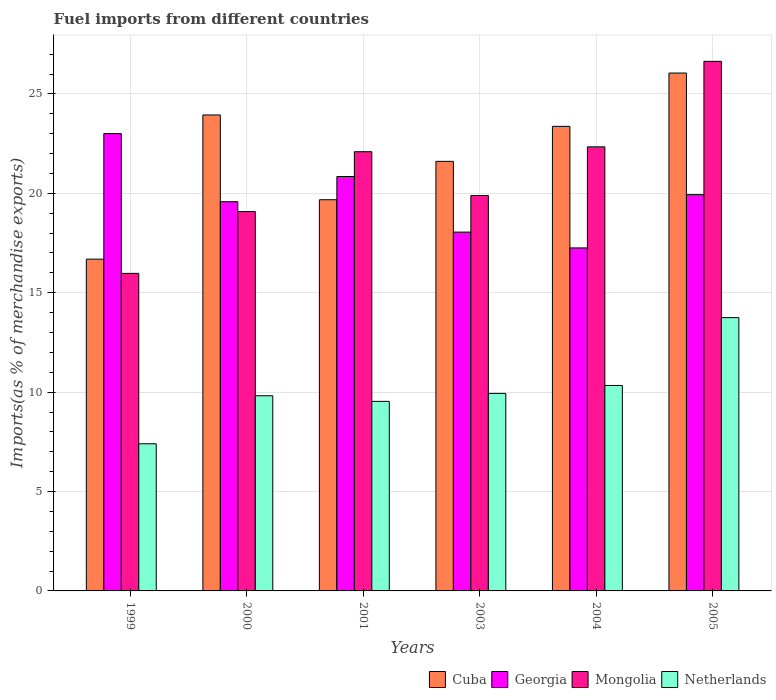Are the number of bars per tick equal to the number of legend labels?
Make the answer very short. Yes. How many bars are there on the 6th tick from the left?
Your answer should be very brief. 4. How many bars are there on the 3rd tick from the right?
Provide a succinct answer. 4. What is the percentage of imports to different countries in Mongolia in 2004?
Provide a short and direct response. 22.34. Across all years, what is the maximum percentage of imports to different countries in Netherlands?
Give a very brief answer. 13.75. Across all years, what is the minimum percentage of imports to different countries in Georgia?
Provide a succinct answer. 17.25. In which year was the percentage of imports to different countries in Georgia minimum?
Offer a terse response. 2004. What is the total percentage of imports to different countries in Georgia in the graph?
Give a very brief answer. 118.67. What is the difference between the percentage of imports to different countries in Georgia in 2001 and that in 2005?
Give a very brief answer. 0.91. What is the difference between the percentage of imports to different countries in Mongolia in 2000 and the percentage of imports to different countries in Cuba in 2001?
Make the answer very short. -0.6. What is the average percentage of imports to different countries in Georgia per year?
Make the answer very short. 19.78. In the year 2003, what is the difference between the percentage of imports to different countries in Netherlands and percentage of imports to different countries in Mongolia?
Give a very brief answer. -9.96. In how many years, is the percentage of imports to different countries in Mongolia greater than 20 %?
Your answer should be very brief. 3. What is the ratio of the percentage of imports to different countries in Cuba in 1999 to that in 2004?
Ensure brevity in your answer.  0.71. Is the percentage of imports to different countries in Netherlands in 2003 less than that in 2005?
Ensure brevity in your answer.  Yes. Is the difference between the percentage of imports to different countries in Netherlands in 1999 and 2000 greater than the difference between the percentage of imports to different countries in Mongolia in 1999 and 2000?
Ensure brevity in your answer.  Yes. What is the difference between the highest and the second highest percentage of imports to different countries in Georgia?
Your response must be concise. 2.16. What is the difference between the highest and the lowest percentage of imports to different countries in Mongolia?
Ensure brevity in your answer.  10.67. In how many years, is the percentage of imports to different countries in Mongolia greater than the average percentage of imports to different countries in Mongolia taken over all years?
Give a very brief answer. 3. Is it the case that in every year, the sum of the percentage of imports to different countries in Georgia and percentage of imports to different countries in Mongolia is greater than the sum of percentage of imports to different countries in Cuba and percentage of imports to different countries in Netherlands?
Ensure brevity in your answer.  Yes. What does the 2nd bar from the left in 2004 represents?
Offer a very short reply. Georgia. What does the 3rd bar from the right in 2001 represents?
Provide a succinct answer. Georgia. How many bars are there?
Your answer should be very brief. 24. Are all the bars in the graph horizontal?
Keep it short and to the point. No. Where does the legend appear in the graph?
Give a very brief answer. Bottom right. How many legend labels are there?
Your answer should be compact. 4. How are the legend labels stacked?
Your answer should be very brief. Horizontal. What is the title of the graph?
Give a very brief answer. Fuel imports from different countries. Does "Israel" appear as one of the legend labels in the graph?
Ensure brevity in your answer.  No. What is the label or title of the X-axis?
Ensure brevity in your answer.  Years. What is the label or title of the Y-axis?
Your answer should be compact. Imports(as % of merchandise exports). What is the Imports(as % of merchandise exports) in Cuba in 1999?
Your response must be concise. 16.69. What is the Imports(as % of merchandise exports) of Georgia in 1999?
Provide a short and direct response. 23. What is the Imports(as % of merchandise exports) in Mongolia in 1999?
Provide a succinct answer. 15.97. What is the Imports(as % of merchandise exports) of Netherlands in 1999?
Your answer should be very brief. 7.4. What is the Imports(as % of merchandise exports) of Cuba in 2000?
Give a very brief answer. 23.94. What is the Imports(as % of merchandise exports) in Georgia in 2000?
Your answer should be very brief. 19.58. What is the Imports(as % of merchandise exports) of Mongolia in 2000?
Provide a short and direct response. 19.08. What is the Imports(as % of merchandise exports) of Netherlands in 2000?
Keep it short and to the point. 9.82. What is the Imports(as % of merchandise exports) of Cuba in 2001?
Your answer should be compact. 19.68. What is the Imports(as % of merchandise exports) in Georgia in 2001?
Keep it short and to the point. 20.85. What is the Imports(as % of merchandise exports) in Mongolia in 2001?
Your answer should be very brief. 22.09. What is the Imports(as % of merchandise exports) of Netherlands in 2001?
Make the answer very short. 9.53. What is the Imports(as % of merchandise exports) of Cuba in 2003?
Provide a succinct answer. 21.61. What is the Imports(as % of merchandise exports) in Georgia in 2003?
Provide a succinct answer. 18.05. What is the Imports(as % of merchandise exports) in Mongolia in 2003?
Offer a terse response. 19.89. What is the Imports(as % of merchandise exports) in Netherlands in 2003?
Your answer should be compact. 9.93. What is the Imports(as % of merchandise exports) in Cuba in 2004?
Make the answer very short. 23.37. What is the Imports(as % of merchandise exports) in Georgia in 2004?
Give a very brief answer. 17.25. What is the Imports(as % of merchandise exports) in Mongolia in 2004?
Offer a very short reply. 22.34. What is the Imports(as % of merchandise exports) of Netherlands in 2004?
Ensure brevity in your answer.  10.34. What is the Imports(as % of merchandise exports) of Cuba in 2005?
Keep it short and to the point. 26.05. What is the Imports(as % of merchandise exports) of Georgia in 2005?
Your answer should be very brief. 19.93. What is the Imports(as % of merchandise exports) of Mongolia in 2005?
Your answer should be compact. 26.64. What is the Imports(as % of merchandise exports) in Netherlands in 2005?
Offer a terse response. 13.75. Across all years, what is the maximum Imports(as % of merchandise exports) in Cuba?
Your answer should be compact. 26.05. Across all years, what is the maximum Imports(as % of merchandise exports) in Georgia?
Give a very brief answer. 23. Across all years, what is the maximum Imports(as % of merchandise exports) in Mongolia?
Offer a very short reply. 26.64. Across all years, what is the maximum Imports(as % of merchandise exports) in Netherlands?
Provide a short and direct response. 13.75. Across all years, what is the minimum Imports(as % of merchandise exports) in Cuba?
Your answer should be compact. 16.69. Across all years, what is the minimum Imports(as % of merchandise exports) in Georgia?
Provide a short and direct response. 17.25. Across all years, what is the minimum Imports(as % of merchandise exports) in Mongolia?
Ensure brevity in your answer.  15.97. Across all years, what is the minimum Imports(as % of merchandise exports) of Netherlands?
Provide a succinct answer. 7.4. What is the total Imports(as % of merchandise exports) in Cuba in the graph?
Offer a terse response. 131.34. What is the total Imports(as % of merchandise exports) of Georgia in the graph?
Offer a very short reply. 118.67. What is the total Imports(as % of merchandise exports) of Mongolia in the graph?
Ensure brevity in your answer.  126.02. What is the total Imports(as % of merchandise exports) in Netherlands in the graph?
Offer a terse response. 60.77. What is the difference between the Imports(as % of merchandise exports) in Cuba in 1999 and that in 2000?
Make the answer very short. -7.25. What is the difference between the Imports(as % of merchandise exports) in Georgia in 1999 and that in 2000?
Your answer should be very brief. 3.42. What is the difference between the Imports(as % of merchandise exports) in Mongolia in 1999 and that in 2000?
Keep it short and to the point. -3.11. What is the difference between the Imports(as % of merchandise exports) in Netherlands in 1999 and that in 2000?
Make the answer very short. -2.42. What is the difference between the Imports(as % of merchandise exports) of Cuba in 1999 and that in 2001?
Offer a very short reply. -2.99. What is the difference between the Imports(as % of merchandise exports) of Georgia in 1999 and that in 2001?
Your answer should be compact. 2.16. What is the difference between the Imports(as % of merchandise exports) in Mongolia in 1999 and that in 2001?
Provide a succinct answer. -6.12. What is the difference between the Imports(as % of merchandise exports) of Netherlands in 1999 and that in 2001?
Provide a succinct answer. -2.13. What is the difference between the Imports(as % of merchandise exports) in Cuba in 1999 and that in 2003?
Ensure brevity in your answer.  -4.92. What is the difference between the Imports(as % of merchandise exports) of Georgia in 1999 and that in 2003?
Give a very brief answer. 4.95. What is the difference between the Imports(as % of merchandise exports) of Mongolia in 1999 and that in 2003?
Keep it short and to the point. -3.92. What is the difference between the Imports(as % of merchandise exports) of Netherlands in 1999 and that in 2003?
Ensure brevity in your answer.  -2.53. What is the difference between the Imports(as % of merchandise exports) in Cuba in 1999 and that in 2004?
Make the answer very short. -6.68. What is the difference between the Imports(as % of merchandise exports) of Georgia in 1999 and that in 2004?
Your response must be concise. 5.75. What is the difference between the Imports(as % of merchandise exports) in Mongolia in 1999 and that in 2004?
Offer a very short reply. -6.37. What is the difference between the Imports(as % of merchandise exports) in Netherlands in 1999 and that in 2004?
Your answer should be very brief. -2.93. What is the difference between the Imports(as % of merchandise exports) of Cuba in 1999 and that in 2005?
Offer a terse response. -9.36. What is the difference between the Imports(as % of merchandise exports) in Georgia in 1999 and that in 2005?
Offer a very short reply. 3.07. What is the difference between the Imports(as % of merchandise exports) in Mongolia in 1999 and that in 2005?
Provide a succinct answer. -10.67. What is the difference between the Imports(as % of merchandise exports) of Netherlands in 1999 and that in 2005?
Make the answer very short. -6.35. What is the difference between the Imports(as % of merchandise exports) in Cuba in 2000 and that in 2001?
Offer a terse response. 4.26. What is the difference between the Imports(as % of merchandise exports) of Georgia in 2000 and that in 2001?
Make the answer very short. -1.27. What is the difference between the Imports(as % of merchandise exports) of Mongolia in 2000 and that in 2001?
Offer a very short reply. -3.01. What is the difference between the Imports(as % of merchandise exports) of Netherlands in 2000 and that in 2001?
Provide a succinct answer. 0.28. What is the difference between the Imports(as % of merchandise exports) in Cuba in 2000 and that in 2003?
Your answer should be compact. 2.33. What is the difference between the Imports(as % of merchandise exports) of Georgia in 2000 and that in 2003?
Your answer should be very brief. 1.53. What is the difference between the Imports(as % of merchandise exports) in Mongolia in 2000 and that in 2003?
Your answer should be very brief. -0.81. What is the difference between the Imports(as % of merchandise exports) of Netherlands in 2000 and that in 2003?
Provide a short and direct response. -0.12. What is the difference between the Imports(as % of merchandise exports) of Cuba in 2000 and that in 2004?
Make the answer very short. 0.57. What is the difference between the Imports(as % of merchandise exports) of Georgia in 2000 and that in 2004?
Make the answer very short. 2.33. What is the difference between the Imports(as % of merchandise exports) in Mongolia in 2000 and that in 2004?
Your answer should be compact. -3.26. What is the difference between the Imports(as % of merchandise exports) in Netherlands in 2000 and that in 2004?
Offer a very short reply. -0.52. What is the difference between the Imports(as % of merchandise exports) of Cuba in 2000 and that in 2005?
Your response must be concise. -2.11. What is the difference between the Imports(as % of merchandise exports) of Georgia in 2000 and that in 2005?
Provide a succinct answer. -0.36. What is the difference between the Imports(as % of merchandise exports) of Mongolia in 2000 and that in 2005?
Keep it short and to the point. -7.56. What is the difference between the Imports(as % of merchandise exports) of Netherlands in 2000 and that in 2005?
Your answer should be compact. -3.93. What is the difference between the Imports(as % of merchandise exports) in Cuba in 2001 and that in 2003?
Ensure brevity in your answer.  -1.93. What is the difference between the Imports(as % of merchandise exports) of Georgia in 2001 and that in 2003?
Keep it short and to the point. 2.8. What is the difference between the Imports(as % of merchandise exports) in Mongolia in 2001 and that in 2003?
Your answer should be compact. 2.2. What is the difference between the Imports(as % of merchandise exports) in Netherlands in 2001 and that in 2003?
Keep it short and to the point. -0.4. What is the difference between the Imports(as % of merchandise exports) in Cuba in 2001 and that in 2004?
Your answer should be very brief. -3.69. What is the difference between the Imports(as % of merchandise exports) in Georgia in 2001 and that in 2004?
Make the answer very short. 3.59. What is the difference between the Imports(as % of merchandise exports) in Mongolia in 2001 and that in 2004?
Give a very brief answer. -0.24. What is the difference between the Imports(as % of merchandise exports) in Netherlands in 2001 and that in 2004?
Provide a short and direct response. -0.8. What is the difference between the Imports(as % of merchandise exports) of Cuba in 2001 and that in 2005?
Give a very brief answer. -6.37. What is the difference between the Imports(as % of merchandise exports) in Georgia in 2001 and that in 2005?
Provide a succinct answer. 0.91. What is the difference between the Imports(as % of merchandise exports) in Mongolia in 2001 and that in 2005?
Provide a succinct answer. -4.54. What is the difference between the Imports(as % of merchandise exports) of Netherlands in 2001 and that in 2005?
Provide a succinct answer. -4.21. What is the difference between the Imports(as % of merchandise exports) of Cuba in 2003 and that in 2004?
Your answer should be very brief. -1.76. What is the difference between the Imports(as % of merchandise exports) of Georgia in 2003 and that in 2004?
Your answer should be very brief. 0.8. What is the difference between the Imports(as % of merchandise exports) of Mongolia in 2003 and that in 2004?
Your answer should be compact. -2.45. What is the difference between the Imports(as % of merchandise exports) in Netherlands in 2003 and that in 2004?
Your answer should be compact. -0.4. What is the difference between the Imports(as % of merchandise exports) of Cuba in 2003 and that in 2005?
Keep it short and to the point. -4.44. What is the difference between the Imports(as % of merchandise exports) of Georgia in 2003 and that in 2005?
Offer a terse response. -1.89. What is the difference between the Imports(as % of merchandise exports) of Mongolia in 2003 and that in 2005?
Keep it short and to the point. -6.75. What is the difference between the Imports(as % of merchandise exports) of Netherlands in 2003 and that in 2005?
Provide a short and direct response. -3.81. What is the difference between the Imports(as % of merchandise exports) of Cuba in 2004 and that in 2005?
Offer a terse response. -2.68. What is the difference between the Imports(as % of merchandise exports) of Georgia in 2004 and that in 2005?
Offer a very short reply. -2.68. What is the difference between the Imports(as % of merchandise exports) of Mongolia in 2004 and that in 2005?
Your answer should be very brief. -4.3. What is the difference between the Imports(as % of merchandise exports) of Netherlands in 2004 and that in 2005?
Your answer should be very brief. -3.41. What is the difference between the Imports(as % of merchandise exports) in Cuba in 1999 and the Imports(as % of merchandise exports) in Georgia in 2000?
Provide a succinct answer. -2.89. What is the difference between the Imports(as % of merchandise exports) in Cuba in 1999 and the Imports(as % of merchandise exports) in Mongolia in 2000?
Ensure brevity in your answer.  -2.39. What is the difference between the Imports(as % of merchandise exports) in Cuba in 1999 and the Imports(as % of merchandise exports) in Netherlands in 2000?
Offer a very short reply. 6.87. What is the difference between the Imports(as % of merchandise exports) of Georgia in 1999 and the Imports(as % of merchandise exports) of Mongolia in 2000?
Provide a short and direct response. 3.92. What is the difference between the Imports(as % of merchandise exports) in Georgia in 1999 and the Imports(as % of merchandise exports) in Netherlands in 2000?
Keep it short and to the point. 13.19. What is the difference between the Imports(as % of merchandise exports) in Mongolia in 1999 and the Imports(as % of merchandise exports) in Netherlands in 2000?
Your answer should be very brief. 6.16. What is the difference between the Imports(as % of merchandise exports) in Cuba in 1999 and the Imports(as % of merchandise exports) in Georgia in 2001?
Keep it short and to the point. -4.16. What is the difference between the Imports(as % of merchandise exports) of Cuba in 1999 and the Imports(as % of merchandise exports) of Mongolia in 2001?
Make the answer very short. -5.4. What is the difference between the Imports(as % of merchandise exports) of Cuba in 1999 and the Imports(as % of merchandise exports) of Netherlands in 2001?
Give a very brief answer. 7.16. What is the difference between the Imports(as % of merchandise exports) of Georgia in 1999 and the Imports(as % of merchandise exports) of Mongolia in 2001?
Your answer should be very brief. 0.91. What is the difference between the Imports(as % of merchandise exports) of Georgia in 1999 and the Imports(as % of merchandise exports) of Netherlands in 2001?
Ensure brevity in your answer.  13.47. What is the difference between the Imports(as % of merchandise exports) of Mongolia in 1999 and the Imports(as % of merchandise exports) of Netherlands in 2001?
Make the answer very short. 6.44. What is the difference between the Imports(as % of merchandise exports) of Cuba in 1999 and the Imports(as % of merchandise exports) of Georgia in 2003?
Ensure brevity in your answer.  -1.36. What is the difference between the Imports(as % of merchandise exports) of Cuba in 1999 and the Imports(as % of merchandise exports) of Mongolia in 2003?
Your answer should be compact. -3.2. What is the difference between the Imports(as % of merchandise exports) of Cuba in 1999 and the Imports(as % of merchandise exports) of Netherlands in 2003?
Ensure brevity in your answer.  6.76. What is the difference between the Imports(as % of merchandise exports) in Georgia in 1999 and the Imports(as % of merchandise exports) in Mongolia in 2003?
Give a very brief answer. 3.11. What is the difference between the Imports(as % of merchandise exports) in Georgia in 1999 and the Imports(as % of merchandise exports) in Netherlands in 2003?
Your response must be concise. 13.07. What is the difference between the Imports(as % of merchandise exports) in Mongolia in 1999 and the Imports(as % of merchandise exports) in Netherlands in 2003?
Ensure brevity in your answer.  6.04. What is the difference between the Imports(as % of merchandise exports) of Cuba in 1999 and the Imports(as % of merchandise exports) of Georgia in 2004?
Offer a terse response. -0.56. What is the difference between the Imports(as % of merchandise exports) of Cuba in 1999 and the Imports(as % of merchandise exports) of Mongolia in 2004?
Offer a very short reply. -5.65. What is the difference between the Imports(as % of merchandise exports) in Cuba in 1999 and the Imports(as % of merchandise exports) in Netherlands in 2004?
Provide a succinct answer. 6.35. What is the difference between the Imports(as % of merchandise exports) of Georgia in 1999 and the Imports(as % of merchandise exports) of Mongolia in 2004?
Ensure brevity in your answer.  0.67. What is the difference between the Imports(as % of merchandise exports) in Georgia in 1999 and the Imports(as % of merchandise exports) in Netherlands in 2004?
Your answer should be very brief. 12.67. What is the difference between the Imports(as % of merchandise exports) in Mongolia in 1999 and the Imports(as % of merchandise exports) in Netherlands in 2004?
Ensure brevity in your answer.  5.64. What is the difference between the Imports(as % of merchandise exports) of Cuba in 1999 and the Imports(as % of merchandise exports) of Georgia in 2005?
Make the answer very short. -3.24. What is the difference between the Imports(as % of merchandise exports) in Cuba in 1999 and the Imports(as % of merchandise exports) in Mongolia in 2005?
Offer a very short reply. -9.95. What is the difference between the Imports(as % of merchandise exports) in Cuba in 1999 and the Imports(as % of merchandise exports) in Netherlands in 2005?
Your answer should be compact. 2.94. What is the difference between the Imports(as % of merchandise exports) of Georgia in 1999 and the Imports(as % of merchandise exports) of Mongolia in 2005?
Make the answer very short. -3.63. What is the difference between the Imports(as % of merchandise exports) of Georgia in 1999 and the Imports(as % of merchandise exports) of Netherlands in 2005?
Offer a very short reply. 9.26. What is the difference between the Imports(as % of merchandise exports) in Mongolia in 1999 and the Imports(as % of merchandise exports) in Netherlands in 2005?
Give a very brief answer. 2.23. What is the difference between the Imports(as % of merchandise exports) in Cuba in 2000 and the Imports(as % of merchandise exports) in Georgia in 2001?
Your answer should be very brief. 3.1. What is the difference between the Imports(as % of merchandise exports) in Cuba in 2000 and the Imports(as % of merchandise exports) in Mongolia in 2001?
Your answer should be compact. 1.85. What is the difference between the Imports(as % of merchandise exports) in Cuba in 2000 and the Imports(as % of merchandise exports) in Netherlands in 2001?
Give a very brief answer. 14.41. What is the difference between the Imports(as % of merchandise exports) of Georgia in 2000 and the Imports(as % of merchandise exports) of Mongolia in 2001?
Make the answer very short. -2.51. What is the difference between the Imports(as % of merchandise exports) in Georgia in 2000 and the Imports(as % of merchandise exports) in Netherlands in 2001?
Ensure brevity in your answer.  10.04. What is the difference between the Imports(as % of merchandise exports) of Mongolia in 2000 and the Imports(as % of merchandise exports) of Netherlands in 2001?
Keep it short and to the point. 9.55. What is the difference between the Imports(as % of merchandise exports) of Cuba in 2000 and the Imports(as % of merchandise exports) of Georgia in 2003?
Your response must be concise. 5.89. What is the difference between the Imports(as % of merchandise exports) of Cuba in 2000 and the Imports(as % of merchandise exports) of Mongolia in 2003?
Your answer should be compact. 4.05. What is the difference between the Imports(as % of merchandise exports) of Cuba in 2000 and the Imports(as % of merchandise exports) of Netherlands in 2003?
Ensure brevity in your answer.  14.01. What is the difference between the Imports(as % of merchandise exports) of Georgia in 2000 and the Imports(as % of merchandise exports) of Mongolia in 2003?
Offer a terse response. -0.31. What is the difference between the Imports(as % of merchandise exports) in Georgia in 2000 and the Imports(as % of merchandise exports) in Netherlands in 2003?
Ensure brevity in your answer.  9.64. What is the difference between the Imports(as % of merchandise exports) in Mongolia in 2000 and the Imports(as % of merchandise exports) in Netherlands in 2003?
Give a very brief answer. 9.15. What is the difference between the Imports(as % of merchandise exports) of Cuba in 2000 and the Imports(as % of merchandise exports) of Georgia in 2004?
Your answer should be compact. 6.69. What is the difference between the Imports(as % of merchandise exports) of Cuba in 2000 and the Imports(as % of merchandise exports) of Mongolia in 2004?
Make the answer very short. 1.6. What is the difference between the Imports(as % of merchandise exports) in Cuba in 2000 and the Imports(as % of merchandise exports) in Netherlands in 2004?
Your response must be concise. 13.61. What is the difference between the Imports(as % of merchandise exports) in Georgia in 2000 and the Imports(as % of merchandise exports) in Mongolia in 2004?
Provide a short and direct response. -2.76. What is the difference between the Imports(as % of merchandise exports) in Georgia in 2000 and the Imports(as % of merchandise exports) in Netherlands in 2004?
Your response must be concise. 9.24. What is the difference between the Imports(as % of merchandise exports) in Mongolia in 2000 and the Imports(as % of merchandise exports) in Netherlands in 2004?
Ensure brevity in your answer.  8.75. What is the difference between the Imports(as % of merchandise exports) in Cuba in 2000 and the Imports(as % of merchandise exports) in Georgia in 2005?
Provide a succinct answer. 4.01. What is the difference between the Imports(as % of merchandise exports) in Cuba in 2000 and the Imports(as % of merchandise exports) in Mongolia in 2005?
Offer a terse response. -2.7. What is the difference between the Imports(as % of merchandise exports) in Cuba in 2000 and the Imports(as % of merchandise exports) in Netherlands in 2005?
Give a very brief answer. 10.2. What is the difference between the Imports(as % of merchandise exports) of Georgia in 2000 and the Imports(as % of merchandise exports) of Mongolia in 2005?
Your answer should be compact. -7.06. What is the difference between the Imports(as % of merchandise exports) in Georgia in 2000 and the Imports(as % of merchandise exports) in Netherlands in 2005?
Provide a short and direct response. 5.83. What is the difference between the Imports(as % of merchandise exports) of Mongolia in 2000 and the Imports(as % of merchandise exports) of Netherlands in 2005?
Offer a terse response. 5.34. What is the difference between the Imports(as % of merchandise exports) in Cuba in 2001 and the Imports(as % of merchandise exports) in Georgia in 2003?
Make the answer very short. 1.63. What is the difference between the Imports(as % of merchandise exports) of Cuba in 2001 and the Imports(as % of merchandise exports) of Mongolia in 2003?
Provide a succinct answer. -0.21. What is the difference between the Imports(as % of merchandise exports) of Cuba in 2001 and the Imports(as % of merchandise exports) of Netherlands in 2003?
Your response must be concise. 9.74. What is the difference between the Imports(as % of merchandise exports) of Georgia in 2001 and the Imports(as % of merchandise exports) of Mongolia in 2003?
Your answer should be very brief. 0.96. What is the difference between the Imports(as % of merchandise exports) of Georgia in 2001 and the Imports(as % of merchandise exports) of Netherlands in 2003?
Your answer should be compact. 10.91. What is the difference between the Imports(as % of merchandise exports) of Mongolia in 2001 and the Imports(as % of merchandise exports) of Netherlands in 2003?
Keep it short and to the point. 12.16. What is the difference between the Imports(as % of merchandise exports) in Cuba in 2001 and the Imports(as % of merchandise exports) in Georgia in 2004?
Make the answer very short. 2.42. What is the difference between the Imports(as % of merchandise exports) in Cuba in 2001 and the Imports(as % of merchandise exports) in Mongolia in 2004?
Ensure brevity in your answer.  -2.66. What is the difference between the Imports(as % of merchandise exports) of Cuba in 2001 and the Imports(as % of merchandise exports) of Netherlands in 2004?
Offer a very short reply. 9.34. What is the difference between the Imports(as % of merchandise exports) in Georgia in 2001 and the Imports(as % of merchandise exports) in Mongolia in 2004?
Ensure brevity in your answer.  -1.49. What is the difference between the Imports(as % of merchandise exports) of Georgia in 2001 and the Imports(as % of merchandise exports) of Netherlands in 2004?
Give a very brief answer. 10.51. What is the difference between the Imports(as % of merchandise exports) of Mongolia in 2001 and the Imports(as % of merchandise exports) of Netherlands in 2004?
Keep it short and to the point. 11.76. What is the difference between the Imports(as % of merchandise exports) of Cuba in 2001 and the Imports(as % of merchandise exports) of Georgia in 2005?
Make the answer very short. -0.26. What is the difference between the Imports(as % of merchandise exports) in Cuba in 2001 and the Imports(as % of merchandise exports) in Mongolia in 2005?
Your answer should be very brief. -6.96. What is the difference between the Imports(as % of merchandise exports) in Cuba in 2001 and the Imports(as % of merchandise exports) in Netherlands in 2005?
Your response must be concise. 5.93. What is the difference between the Imports(as % of merchandise exports) in Georgia in 2001 and the Imports(as % of merchandise exports) in Mongolia in 2005?
Make the answer very short. -5.79. What is the difference between the Imports(as % of merchandise exports) of Georgia in 2001 and the Imports(as % of merchandise exports) of Netherlands in 2005?
Offer a terse response. 7.1. What is the difference between the Imports(as % of merchandise exports) in Mongolia in 2001 and the Imports(as % of merchandise exports) in Netherlands in 2005?
Provide a short and direct response. 8.35. What is the difference between the Imports(as % of merchandise exports) in Cuba in 2003 and the Imports(as % of merchandise exports) in Georgia in 2004?
Provide a succinct answer. 4.35. What is the difference between the Imports(as % of merchandise exports) in Cuba in 2003 and the Imports(as % of merchandise exports) in Mongolia in 2004?
Your answer should be compact. -0.73. What is the difference between the Imports(as % of merchandise exports) of Cuba in 2003 and the Imports(as % of merchandise exports) of Netherlands in 2004?
Offer a terse response. 11.27. What is the difference between the Imports(as % of merchandise exports) in Georgia in 2003 and the Imports(as % of merchandise exports) in Mongolia in 2004?
Keep it short and to the point. -4.29. What is the difference between the Imports(as % of merchandise exports) in Georgia in 2003 and the Imports(as % of merchandise exports) in Netherlands in 2004?
Your answer should be compact. 7.71. What is the difference between the Imports(as % of merchandise exports) in Mongolia in 2003 and the Imports(as % of merchandise exports) in Netherlands in 2004?
Make the answer very short. 9.56. What is the difference between the Imports(as % of merchandise exports) in Cuba in 2003 and the Imports(as % of merchandise exports) in Georgia in 2005?
Provide a succinct answer. 1.67. What is the difference between the Imports(as % of merchandise exports) of Cuba in 2003 and the Imports(as % of merchandise exports) of Mongolia in 2005?
Give a very brief answer. -5.03. What is the difference between the Imports(as % of merchandise exports) in Cuba in 2003 and the Imports(as % of merchandise exports) in Netherlands in 2005?
Your response must be concise. 7.86. What is the difference between the Imports(as % of merchandise exports) in Georgia in 2003 and the Imports(as % of merchandise exports) in Mongolia in 2005?
Offer a terse response. -8.59. What is the difference between the Imports(as % of merchandise exports) of Georgia in 2003 and the Imports(as % of merchandise exports) of Netherlands in 2005?
Your answer should be very brief. 4.3. What is the difference between the Imports(as % of merchandise exports) in Mongolia in 2003 and the Imports(as % of merchandise exports) in Netherlands in 2005?
Ensure brevity in your answer.  6.14. What is the difference between the Imports(as % of merchandise exports) of Cuba in 2004 and the Imports(as % of merchandise exports) of Georgia in 2005?
Your answer should be compact. 3.43. What is the difference between the Imports(as % of merchandise exports) of Cuba in 2004 and the Imports(as % of merchandise exports) of Mongolia in 2005?
Make the answer very short. -3.27. What is the difference between the Imports(as % of merchandise exports) in Cuba in 2004 and the Imports(as % of merchandise exports) in Netherlands in 2005?
Your answer should be very brief. 9.62. What is the difference between the Imports(as % of merchandise exports) of Georgia in 2004 and the Imports(as % of merchandise exports) of Mongolia in 2005?
Your response must be concise. -9.38. What is the difference between the Imports(as % of merchandise exports) of Georgia in 2004 and the Imports(as % of merchandise exports) of Netherlands in 2005?
Offer a very short reply. 3.51. What is the difference between the Imports(as % of merchandise exports) of Mongolia in 2004 and the Imports(as % of merchandise exports) of Netherlands in 2005?
Ensure brevity in your answer.  8.59. What is the average Imports(as % of merchandise exports) of Cuba per year?
Make the answer very short. 21.89. What is the average Imports(as % of merchandise exports) of Georgia per year?
Offer a terse response. 19.78. What is the average Imports(as % of merchandise exports) in Mongolia per year?
Your answer should be compact. 21. What is the average Imports(as % of merchandise exports) of Netherlands per year?
Offer a very short reply. 10.13. In the year 1999, what is the difference between the Imports(as % of merchandise exports) of Cuba and Imports(as % of merchandise exports) of Georgia?
Your answer should be very brief. -6.31. In the year 1999, what is the difference between the Imports(as % of merchandise exports) in Cuba and Imports(as % of merchandise exports) in Mongolia?
Provide a short and direct response. 0.72. In the year 1999, what is the difference between the Imports(as % of merchandise exports) of Cuba and Imports(as % of merchandise exports) of Netherlands?
Your answer should be compact. 9.29. In the year 1999, what is the difference between the Imports(as % of merchandise exports) of Georgia and Imports(as % of merchandise exports) of Mongolia?
Your answer should be very brief. 7.03. In the year 1999, what is the difference between the Imports(as % of merchandise exports) of Georgia and Imports(as % of merchandise exports) of Netherlands?
Offer a terse response. 15.6. In the year 1999, what is the difference between the Imports(as % of merchandise exports) in Mongolia and Imports(as % of merchandise exports) in Netherlands?
Your answer should be compact. 8.57. In the year 2000, what is the difference between the Imports(as % of merchandise exports) in Cuba and Imports(as % of merchandise exports) in Georgia?
Give a very brief answer. 4.36. In the year 2000, what is the difference between the Imports(as % of merchandise exports) of Cuba and Imports(as % of merchandise exports) of Mongolia?
Give a very brief answer. 4.86. In the year 2000, what is the difference between the Imports(as % of merchandise exports) of Cuba and Imports(as % of merchandise exports) of Netherlands?
Offer a very short reply. 14.12. In the year 2000, what is the difference between the Imports(as % of merchandise exports) in Georgia and Imports(as % of merchandise exports) in Mongolia?
Keep it short and to the point. 0.5. In the year 2000, what is the difference between the Imports(as % of merchandise exports) in Georgia and Imports(as % of merchandise exports) in Netherlands?
Your answer should be very brief. 9.76. In the year 2000, what is the difference between the Imports(as % of merchandise exports) of Mongolia and Imports(as % of merchandise exports) of Netherlands?
Make the answer very short. 9.26. In the year 2001, what is the difference between the Imports(as % of merchandise exports) of Cuba and Imports(as % of merchandise exports) of Georgia?
Your answer should be very brief. -1.17. In the year 2001, what is the difference between the Imports(as % of merchandise exports) in Cuba and Imports(as % of merchandise exports) in Mongolia?
Your answer should be very brief. -2.42. In the year 2001, what is the difference between the Imports(as % of merchandise exports) of Cuba and Imports(as % of merchandise exports) of Netherlands?
Provide a short and direct response. 10.14. In the year 2001, what is the difference between the Imports(as % of merchandise exports) of Georgia and Imports(as % of merchandise exports) of Mongolia?
Offer a very short reply. -1.25. In the year 2001, what is the difference between the Imports(as % of merchandise exports) in Georgia and Imports(as % of merchandise exports) in Netherlands?
Your response must be concise. 11.31. In the year 2001, what is the difference between the Imports(as % of merchandise exports) in Mongolia and Imports(as % of merchandise exports) in Netherlands?
Your answer should be very brief. 12.56. In the year 2003, what is the difference between the Imports(as % of merchandise exports) in Cuba and Imports(as % of merchandise exports) in Georgia?
Keep it short and to the point. 3.56. In the year 2003, what is the difference between the Imports(as % of merchandise exports) of Cuba and Imports(as % of merchandise exports) of Mongolia?
Make the answer very short. 1.72. In the year 2003, what is the difference between the Imports(as % of merchandise exports) in Cuba and Imports(as % of merchandise exports) in Netherlands?
Give a very brief answer. 11.67. In the year 2003, what is the difference between the Imports(as % of merchandise exports) in Georgia and Imports(as % of merchandise exports) in Mongolia?
Ensure brevity in your answer.  -1.84. In the year 2003, what is the difference between the Imports(as % of merchandise exports) of Georgia and Imports(as % of merchandise exports) of Netherlands?
Give a very brief answer. 8.11. In the year 2003, what is the difference between the Imports(as % of merchandise exports) of Mongolia and Imports(as % of merchandise exports) of Netherlands?
Keep it short and to the point. 9.96. In the year 2004, what is the difference between the Imports(as % of merchandise exports) of Cuba and Imports(as % of merchandise exports) of Georgia?
Provide a short and direct response. 6.12. In the year 2004, what is the difference between the Imports(as % of merchandise exports) of Cuba and Imports(as % of merchandise exports) of Mongolia?
Your answer should be compact. 1.03. In the year 2004, what is the difference between the Imports(as % of merchandise exports) in Cuba and Imports(as % of merchandise exports) in Netherlands?
Provide a succinct answer. 13.03. In the year 2004, what is the difference between the Imports(as % of merchandise exports) of Georgia and Imports(as % of merchandise exports) of Mongolia?
Offer a terse response. -5.08. In the year 2004, what is the difference between the Imports(as % of merchandise exports) in Georgia and Imports(as % of merchandise exports) in Netherlands?
Make the answer very short. 6.92. In the year 2004, what is the difference between the Imports(as % of merchandise exports) of Mongolia and Imports(as % of merchandise exports) of Netherlands?
Provide a succinct answer. 12. In the year 2005, what is the difference between the Imports(as % of merchandise exports) in Cuba and Imports(as % of merchandise exports) in Georgia?
Keep it short and to the point. 6.12. In the year 2005, what is the difference between the Imports(as % of merchandise exports) in Cuba and Imports(as % of merchandise exports) in Mongolia?
Your response must be concise. -0.59. In the year 2005, what is the difference between the Imports(as % of merchandise exports) of Cuba and Imports(as % of merchandise exports) of Netherlands?
Your response must be concise. 12.3. In the year 2005, what is the difference between the Imports(as % of merchandise exports) in Georgia and Imports(as % of merchandise exports) in Mongolia?
Your response must be concise. -6.7. In the year 2005, what is the difference between the Imports(as % of merchandise exports) in Georgia and Imports(as % of merchandise exports) in Netherlands?
Keep it short and to the point. 6.19. In the year 2005, what is the difference between the Imports(as % of merchandise exports) of Mongolia and Imports(as % of merchandise exports) of Netherlands?
Your answer should be very brief. 12.89. What is the ratio of the Imports(as % of merchandise exports) in Cuba in 1999 to that in 2000?
Keep it short and to the point. 0.7. What is the ratio of the Imports(as % of merchandise exports) in Georgia in 1999 to that in 2000?
Your answer should be compact. 1.17. What is the ratio of the Imports(as % of merchandise exports) of Mongolia in 1999 to that in 2000?
Your response must be concise. 0.84. What is the ratio of the Imports(as % of merchandise exports) of Netherlands in 1999 to that in 2000?
Ensure brevity in your answer.  0.75. What is the ratio of the Imports(as % of merchandise exports) in Cuba in 1999 to that in 2001?
Provide a short and direct response. 0.85. What is the ratio of the Imports(as % of merchandise exports) in Georgia in 1999 to that in 2001?
Offer a terse response. 1.1. What is the ratio of the Imports(as % of merchandise exports) of Mongolia in 1999 to that in 2001?
Make the answer very short. 0.72. What is the ratio of the Imports(as % of merchandise exports) in Netherlands in 1999 to that in 2001?
Your answer should be compact. 0.78. What is the ratio of the Imports(as % of merchandise exports) of Cuba in 1999 to that in 2003?
Offer a very short reply. 0.77. What is the ratio of the Imports(as % of merchandise exports) in Georgia in 1999 to that in 2003?
Your response must be concise. 1.27. What is the ratio of the Imports(as % of merchandise exports) of Mongolia in 1999 to that in 2003?
Offer a very short reply. 0.8. What is the ratio of the Imports(as % of merchandise exports) in Netherlands in 1999 to that in 2003?
Your response must be concise. 0.74. What is the ratio of the Imports(as % of merchandise exports) in Cuba in 1999 to that in 2004?
Provide a succinct answer. 0.71. What is the ratio of the Imports(as % of merchandise exports) in Mongolia in 1999 to that in 2004?
Offer a very short reply. 0.72. What is the ratio of the Imports(as % of merchandise exports) in Netherlands in 1999 to that in 2004?
Keep it short and to the point. 0.72. What is the ratio of the Imports(as % of merchandise exports) in Cuba in 1999 to that in 2005?
Keep it short and to the point. 0.64. What is the ratio of the Imports(as % of merchandise exports) in Georgia in 1999 to that in 2005?
Make the answer very short. 1.15. What is the ratio of the Imports(as % of merchandise exports) of Mongolia in 1999 to that in 2005?
Keep it short and to the point. 0.6. What is the ratio of the Imports(as % of merchandise exports) of Netherlands in 1999 to that in 2005?
Provide a succinct answer. 0.54. What is the ratio of the Imports(as % of merchandise exports) in Cuba in 2000 to that in 2001?
Keep it short and to the point. 1.22. What is the ratio of the Imports(as % of merchandise exports) of Georgia in 2000 to that in 2001?
Provide a succinct answer. 0.94. What is the ratio of the Imports(as % of merchandise exports) in Mongolia in 2000 to that in 2001?
Provide a short and direct response. 0.86. What is the ratio of the Imports(as % of merchandise exports) of Netherlands in 2000 to that in 2001?
Your answer should be compact. 1.03. What is the ratio of the Imports(as % of merchandise exports) in Cuba in 2000 to that in 2003?
Provide a short and direct response. 1.11. What is the ratio of the Imports(as % of merchandise exports) in Georgia in 2000 to that in 2003?
Your response must be concise. 1.08. What is the ratio of the Imports(as % of merchandise exports) in Mongolia in 2000 to that in 2003?
Keep it short and to the point. 0.96. What is the ratio of the Imports(as % of merchandise exports) in Netherlands in 2000 to that in 2003?
Offer a very short reply. 0.99. What is the ratio of the Imports(as % of merchandise exports) of Cuba in 2000 to that in 2004?
Offer a terse response. 1.02. What is the ratio of the Imports(as % of merchandise exports) of Georgia in 2000 to that in 2004?
Your answer should be compact. 1.13. What is the ratio of the Imports(as % of merchandise exports) of Mongolia in 2000 to that in 2004?
Ensure brevity in your answer.  0.85. What is the ratio of the Imports(as % of merchandise exports) in Netherlands in 2000 to that in 2004?
Your answer should be compact. 0.95. What is the ratio of the Imports(as % of merchandise exports) of Cuba in 2000 to that in 2005?
Your answer should be compact. 0.92. What is the ratio of the Imports(as % of merchandise exports) of Georgia in 2000 to that in 2005?
Provide a succinct answer. 0.98. What is the ratio of the Imports(as % of merchandise exports) of Mongolia in 2000 to that in 2005?
Your response must be concise. 0.72. What is the ratio of the Imports(as % of merchandise exports) in Netherlands in 2000 to that in 2005?
Keep it short and to the point. 0.71. What is the ratio of the Imports(as % of merchandise exports) in Cuba in 2001 to that in 2003?
Provide a short and direct response. 0.91. What is the ratio of the Imports(as % of merchandise exports) of Georgia in 2001 to that in 2003?
Make the answer very short. 1.16. What is the ratio of the Imports(as % of merchandise exports) in Mongolia in 2001 to that in 2003?
Offer a terse response. 1.11. What is the ratio of the Imports(as % of merchandise exports) in Netherlands in 2001 to that in 2003?
Provide a succinct answer. 0.96. What is the ratio of the Imports(as % of merchandise exports) of Cuba in 2001 to that in 2004?
Make the answer very short. 0.84. What is the ratio of the Imports(as % of merchandise exports) of Georgia in 2001 to that in 2004?
Make the answer very short. 1.21. What is the ratio of the Imports(as % of merchandise exports) in Netherlands in 2001 to that in 2004?
Your answer should be very brief. 0.92. What is the ratio of the Imports(as % of merchandise exports) in Cuba in 2001 to that in 2005?
Give a very brief answer. 0.76. What is the ratio of the Imports(as % of merchandise exports) of Georgia in 2001 to that in 2005?
Your response must be concise. 1.05. What is the ratio of the Imports(as % of merchandise exports) of Mongolia in 2001 to that in 2005?
Give a very brief answer. 0.83. What is the ratio of the Imports(as % of merchandise exports) of Netherlands in 2001 to that in 2005?
Your answer should be compact. 0.69. What is the ratio of the Imports(as % of merchandise exports) in Cuba in 2003 to that in 2004?
Your response must be concise. 0.92. What is the ratio of the Imports(as % of merchandise exports) of Georgia in 2003 to that in 2004?
Provide a short and direct response. 1.05. What is the ratio of the Imports(as % of merchandise exports) of Mongolia in 2003 to that in 2004?
Make the answer very short. 0.89. What is the ratio of the Imports(as % of merchandise exports) in Netherlands in 2003 to that in 2004?
Your answer should be compact. 0.96. What is the ratio of the Imports(as % of merchandise exports) in Cuba in 2003 to that in 2005?
Provide a short and direct response. 0.83. What is the ratio of the Imports(as % of merchandise exports) in Georgia in 2003 to that in 2005?
Your answer should be very brief. 0.91. What is the ratio of the Imports(as % of merchandise exports) of Mongolia in 2003 to that in 2005?
Provide a short and direct response. 0.75. What is the ratio of the Imports(as % of merchandise exports) of Netherlands in 2003 to that in 2005?
Offer a very short reply. 0.72. What is the ratio of the Imports(as % of merchandise exports) of Cuba in 2004 to that in 2005?
Your response must be concise. 0.9. What is the ratio of the Imports(as % of merchandise exports) of Georgia in 2004 to that in 2005?
Your response must be concise. 0.87. What is the ratio of the Imports(as % of merchandise exports) of Mongolia in 2004 to that in 2005?
Make the answer very short. 0.84. What is the ratio of the Imports(as % of merchandise exports) in Netherlands in 2004 to that in 2005?
Provide a short and direct response. 0.75. What is the difference between the highest and the second highest Imports(as % of merchandise exports) of Cuba?
Your response must be concise. 2.11. What is the difference between the highest and the second highest Imports(as % of merchandise exports) in Georgia?
Ensure brevity in your answer.  2.16. What is the difference between the highest and the second highest Imports(as % of merchandise exports) in Mongolia?
Provide a succinct answer. 4.3. What is the difference between the highest and the second highest Imports(as % of merchandise exports) in Netherlands?
Offer a terse response. 3.41. What is the difference between the highest and the lowest Imports(as % of merchandise exports) in Cuba?
Offer a terse response. 9.36. What is the difference between the highest and the lowest Imports(as % of merchandise exports) of Georgia?
Your response must be concise. 5.75. What is the difference between the highest and the lowest Imports(as % of merchandise exports) of Mongolia?
Give a very brief answer. 10.67. What is the difference between the highest and the lowest Imports(as % of merchandise exports) of Netherlands?
Offer a terse response. 6.35. 